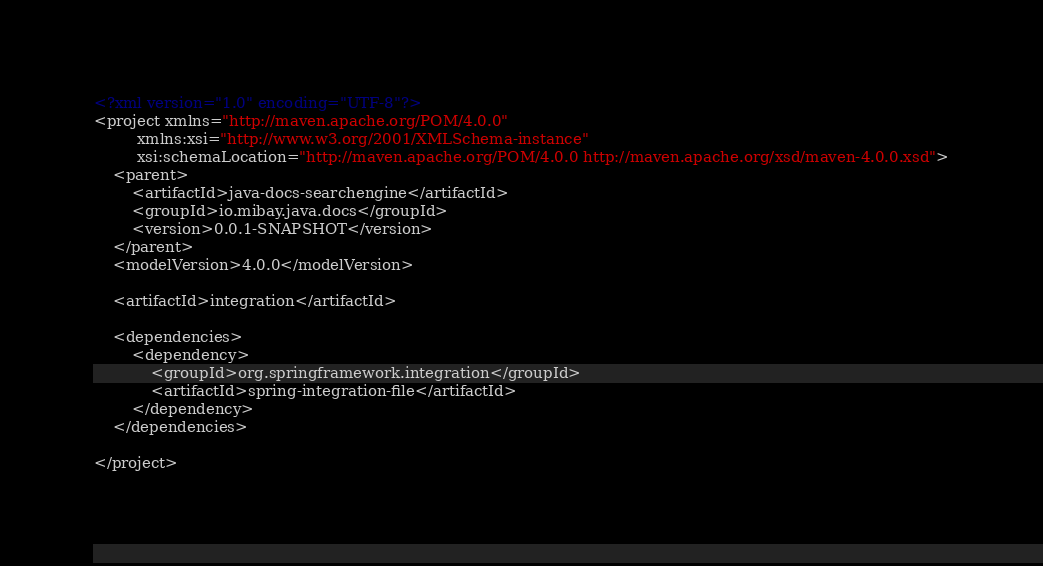<code> <loc_0><loc_0><loc_500><loc_500><_XML_><?xml version="1.0" encoding="UTF-8"?>
<project xmlns="http://maven.apache.org/POM/4.0.0"
         xmlns:xsi="http://www.w3.org/2001/XMLSchema-instance"
         xsi:schemaLocation="http://maven.apache.org/POM/4.0.0 http://maven.apache.org/xsd/maven-4.0.0.xsd">
    <parent>
        <artifactId>java-docs-searchengine</artifactId>
        <groupId>io.mibay.java.docs</groupId>
        <version>0.0.1-SNAPSHOT</version>
    </parent>
    <modelVersion>4.0.0</modelVersion>

    <artifactId>integration</artifactId>

    <dependencies>
        <dependency>
            <groupId>org.springframework.integration</groupId>
            <artifactId>spring-integration-file</artifactId>
        </dependency>
    </dependencies>

</project></code> 